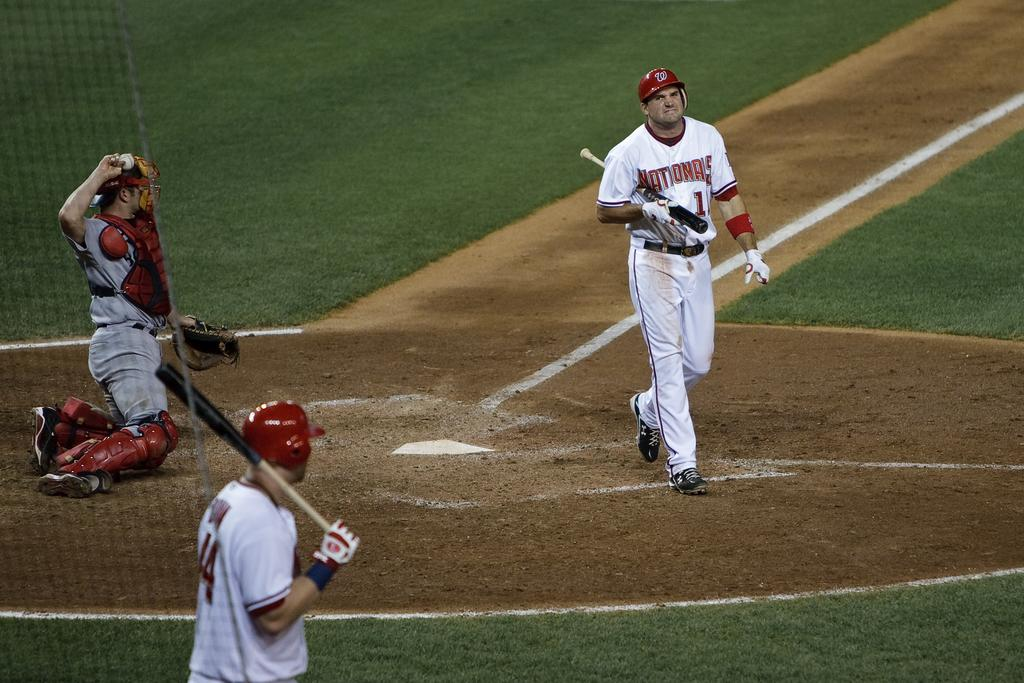<image>
Render a clear and concise summary of the photo. A Nationals player walks back to the dugout after striking out. 